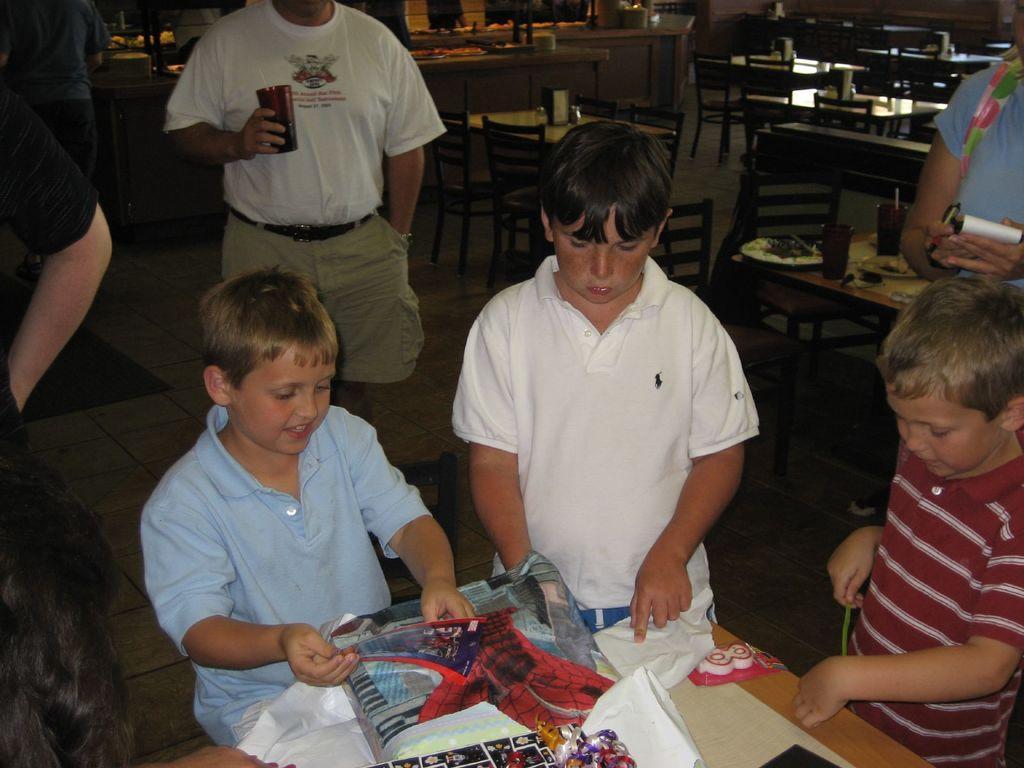Describe this image in one or two sentences. In this picture I can see group of people standing, there are some objects on the tables, and in the background there are chairs. 